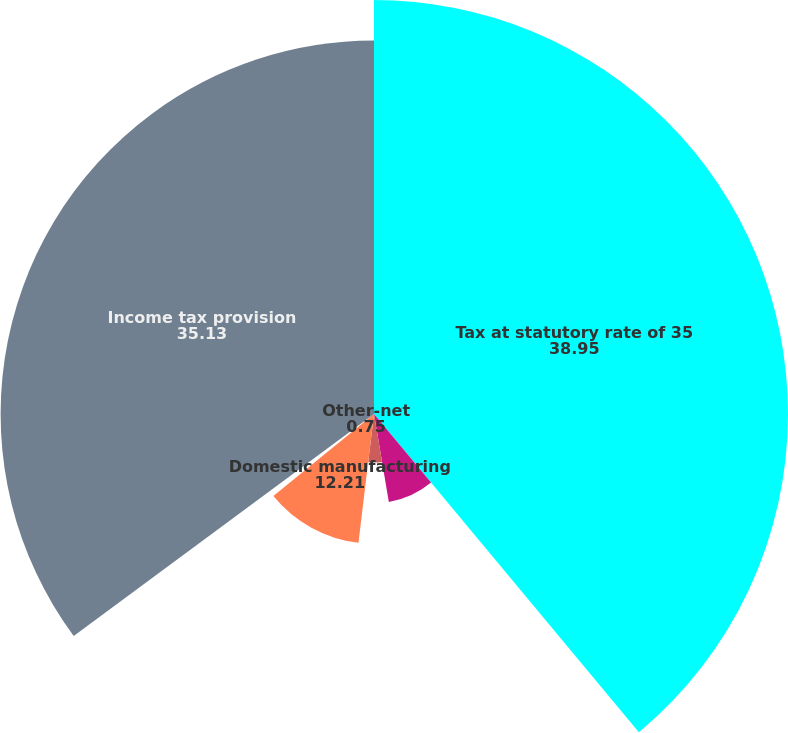Convert chart to OTSL. <chart><loc_0><loc_0><loc_500><loc_500><pie_chart><fcel>Tax at statutory rate of 35<fcel>State and local income taxes<fcel>Foreign rate differential<fcel>Domestic manufacturing<fcel>Other-net<fcel>Income tax provision<nl><fcel>38.95%<fcel>8.39%<fcel>4.57%<fcel>12.21%<fcel>0.75%<fcel>35.13%<nl></chart> 